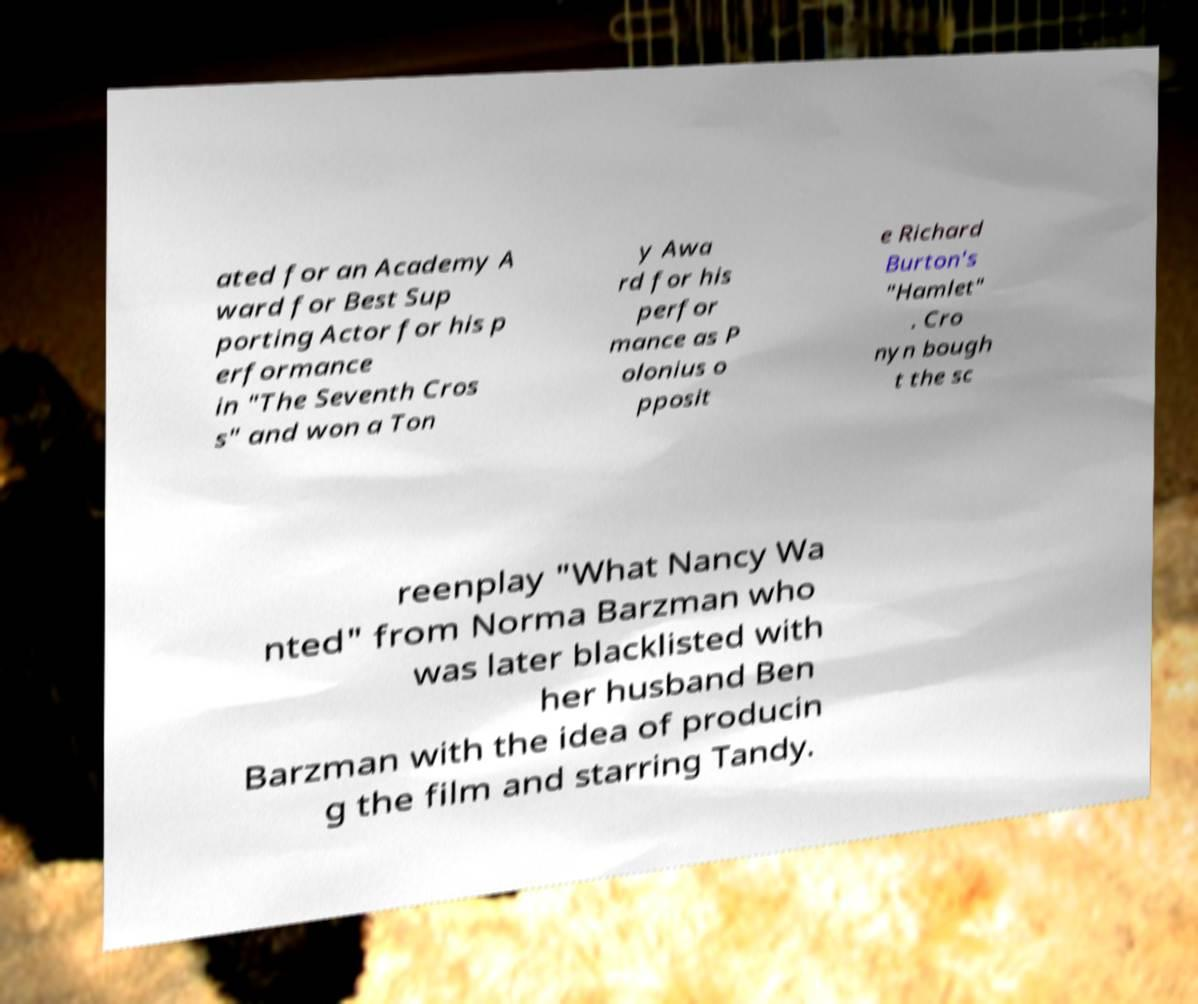I need the written content from this picture converted into text. Can you do that? ated for an Academy A ward for Best Sup porting Actor for his p erformance in "The Seventh Cros s" and won a Ton y Awa rd for his perfor mance as P olonius o pposit e Richard Burton's "Hamlet" . Cro nyn bough t the sc reenplay "What Nancy Wa nted" from Norma Barzman who was later blacklisted with her husband Ben Barzman with the idea of producin g the film and starring Tandy. 